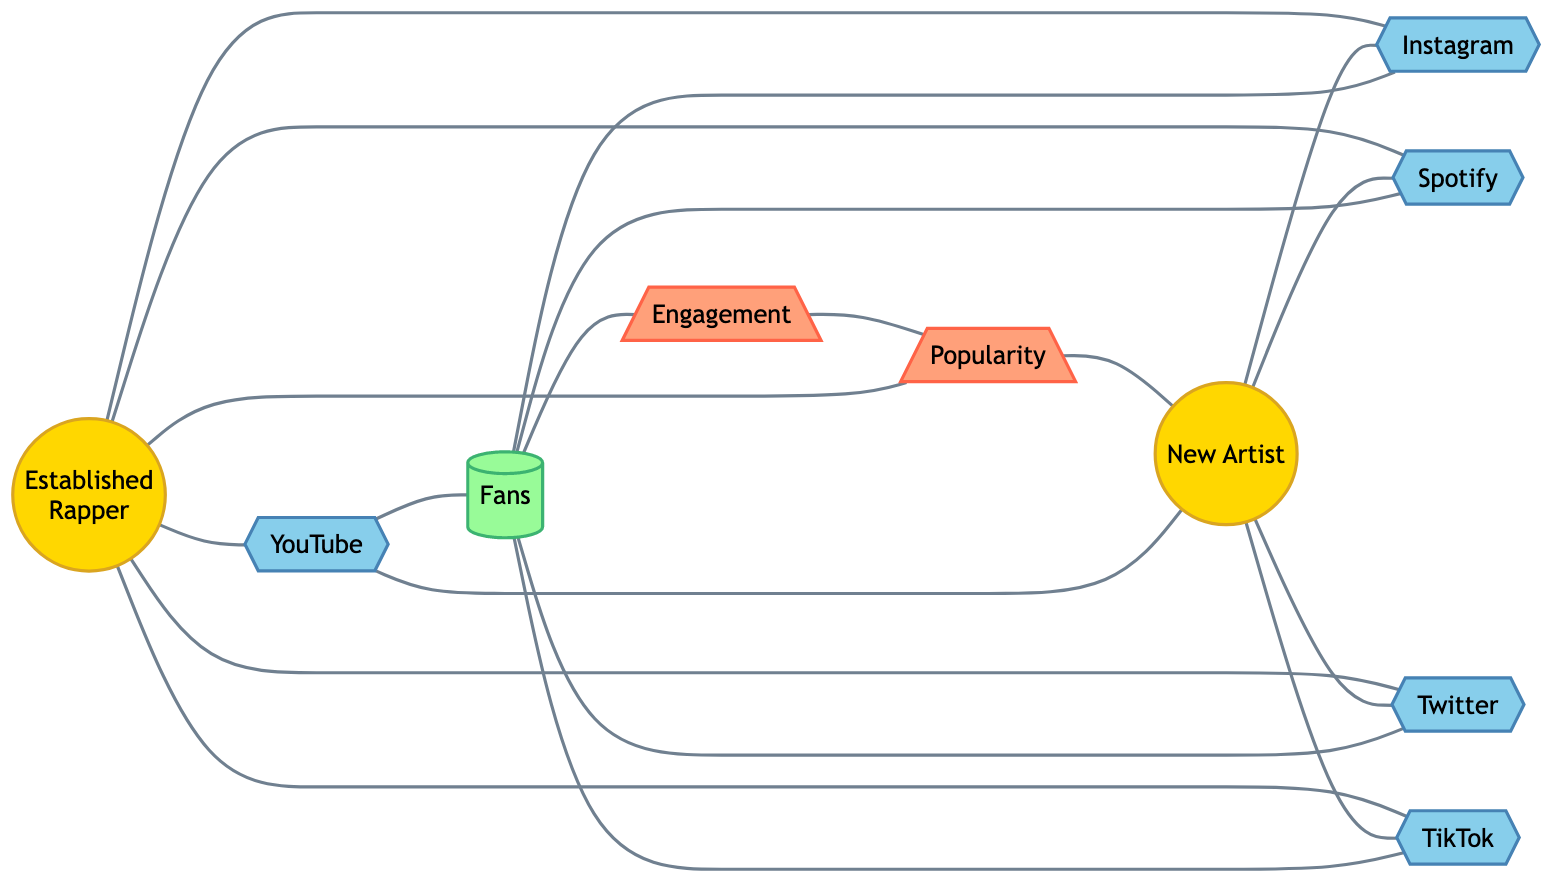What are the total number of nodes in the diagram? The diagram includes 10 nodes, which are: Established Rapper, New Artist, YouTube, Instagram, Spotify, Twitter, TikTok, Fans, Engagement, and Popularity. Counting each one gives a total of 10.
Answer: 10 How many platforms are connected to the established rapper? The established rapper is connected to five platforms: YouTube, Instagram, Spotify, Twitter, and TikTok. Each is counted as a single connection to the rapper.
Answer: 5 Is there a direct connection from new artist to fans? The new artist has no direct edge leading to fans; instead, new artist connects to platforms which then connect to fans, suggesting an indirect relationship. Therefore, there is no direct edge from new artist to fans.
Answer: No What connects engagement to popularity? The connection from engagement to popularity indicates that increased engagement directly influences popularity in the graph structure. Hence, it is the single direct connection.
Answer: Popularity Which artist has a greater connection to fans? Both established rapper and new artist have indirect paths to fans via the same platforms. Since the paths are identical for both artists, it could be classified as even or equal in terms of connections to fans through platforms.
Answer: Equal How many edges are connected to platforms? Each platform connects to fans directly. There are five distinct platforms, leading to a total of five edges that connect platforms to fans; thus, the answer reflects all platforms' reach to the fan node.
Answer: 5 Do both artists contribute to the same popularity node? Yes, both artists have a connection to the popularity node. Each artist is connected to the node, indicating their involvement in the popularity metric within the diagram context.
Answer: Yes What relationship do fans have with engagement? The fans are directly connected to the engagement node, reflecting that fans’ participation or activity leads to engagement in this diagram. This shows an important relationship for understanding audience dynamics.
Answer: Engagement 